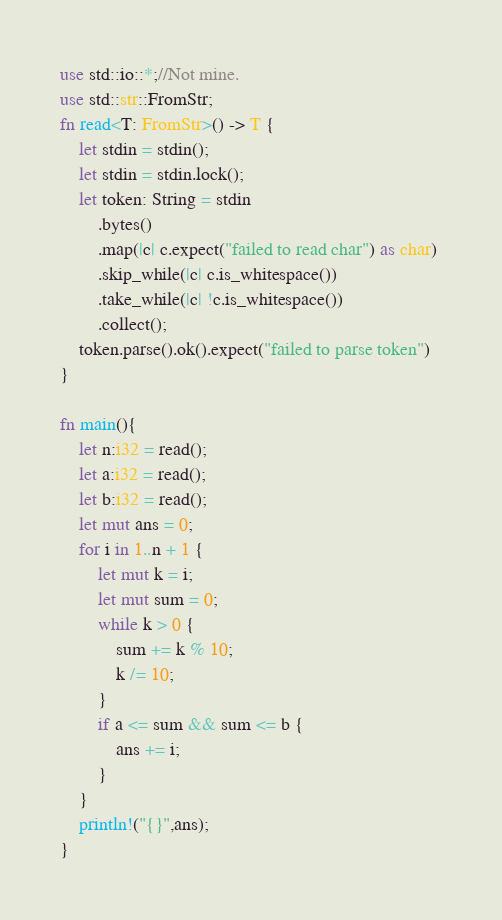<code> <loc_0><loc_0><loc_500><loc_500><_Rust_>use std::io::*;//Not mine.
use std::str::FromStr;
fn read<T: FromStr>() -> T {
    let stdin = stdin();
    let stdin = stdin.lock();
    let token: String = stdin
        .bytes()
        .map(|c| c.expect("failed to read char") as char) 
        .skip_while(|c| c.is_whitespace())
        .take_while(|c| !c.is_whitespace())
        .collect();
    token.parse().ok().expect("failed to parse token")
}

fn main(){
    let n:i32 = read();
    let a:i32 = read();
    let b:i32 = read();
    let mut ans = 0;
    for i in 1..n + 1 {
        let mut k = i;
        let mut sum = 0;
        while k > 0 {
            sum += k % 10;
            k /= 10;
        }
        if a <= sum && sum <= b {
            ans += i;
        }
    }
    println!("{}",ans);
}</code> 